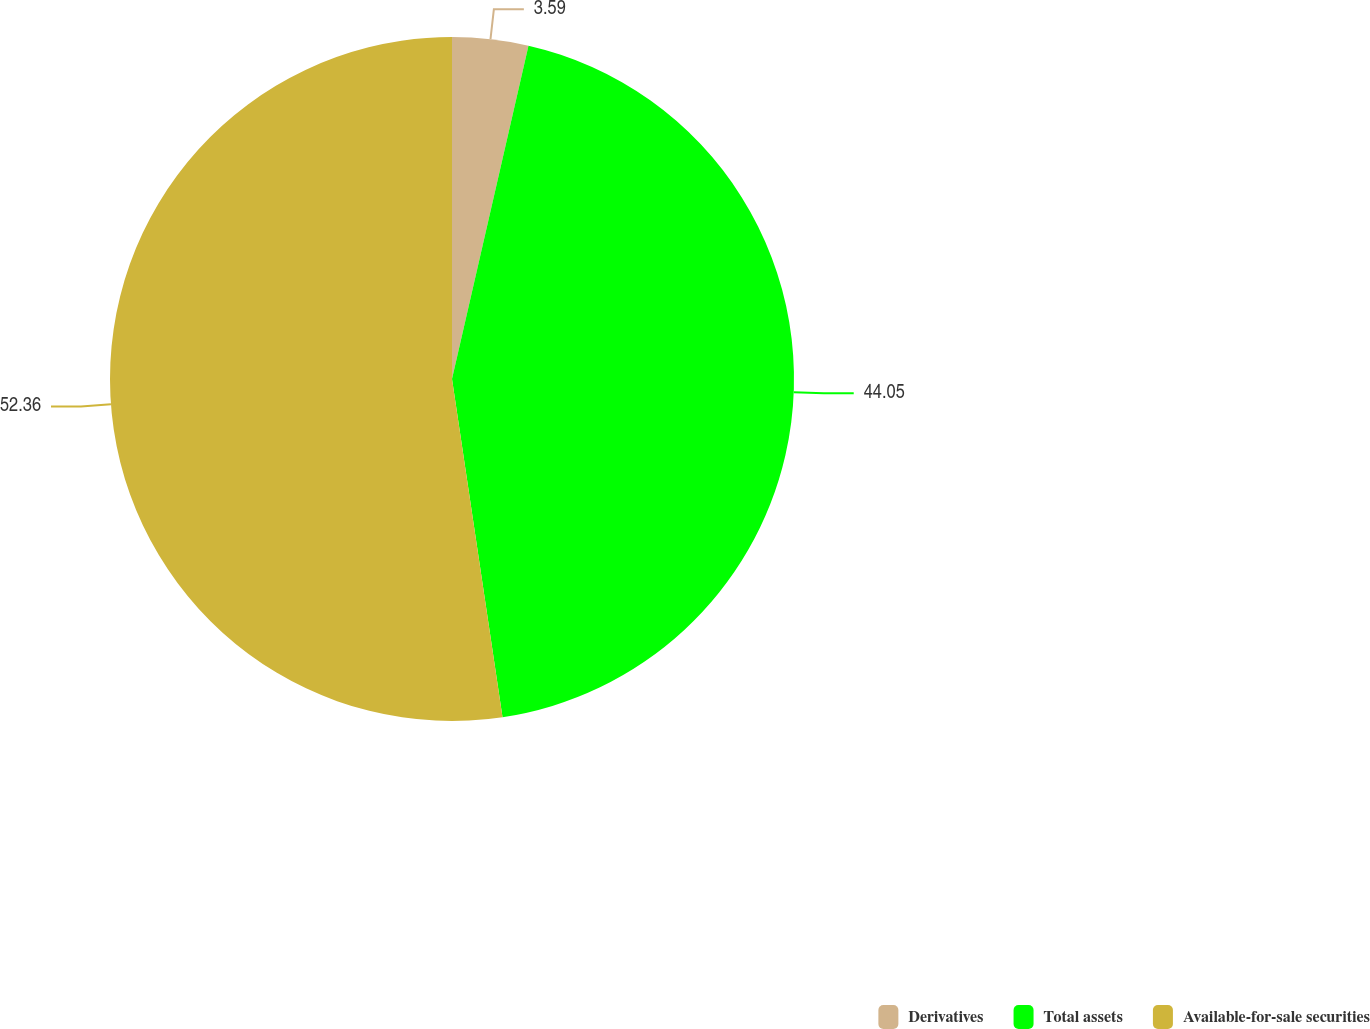Convert chart to OTSL. <chart><loc_0><loc_0><loc_500><loc_500><pie_chart><fcel>Derivatives<fcel>Total assets<fcel>Available-for-sale securities<nl><fcel>3.59%<fcel>44.05%<fcel>52.36%<nl></chart> 